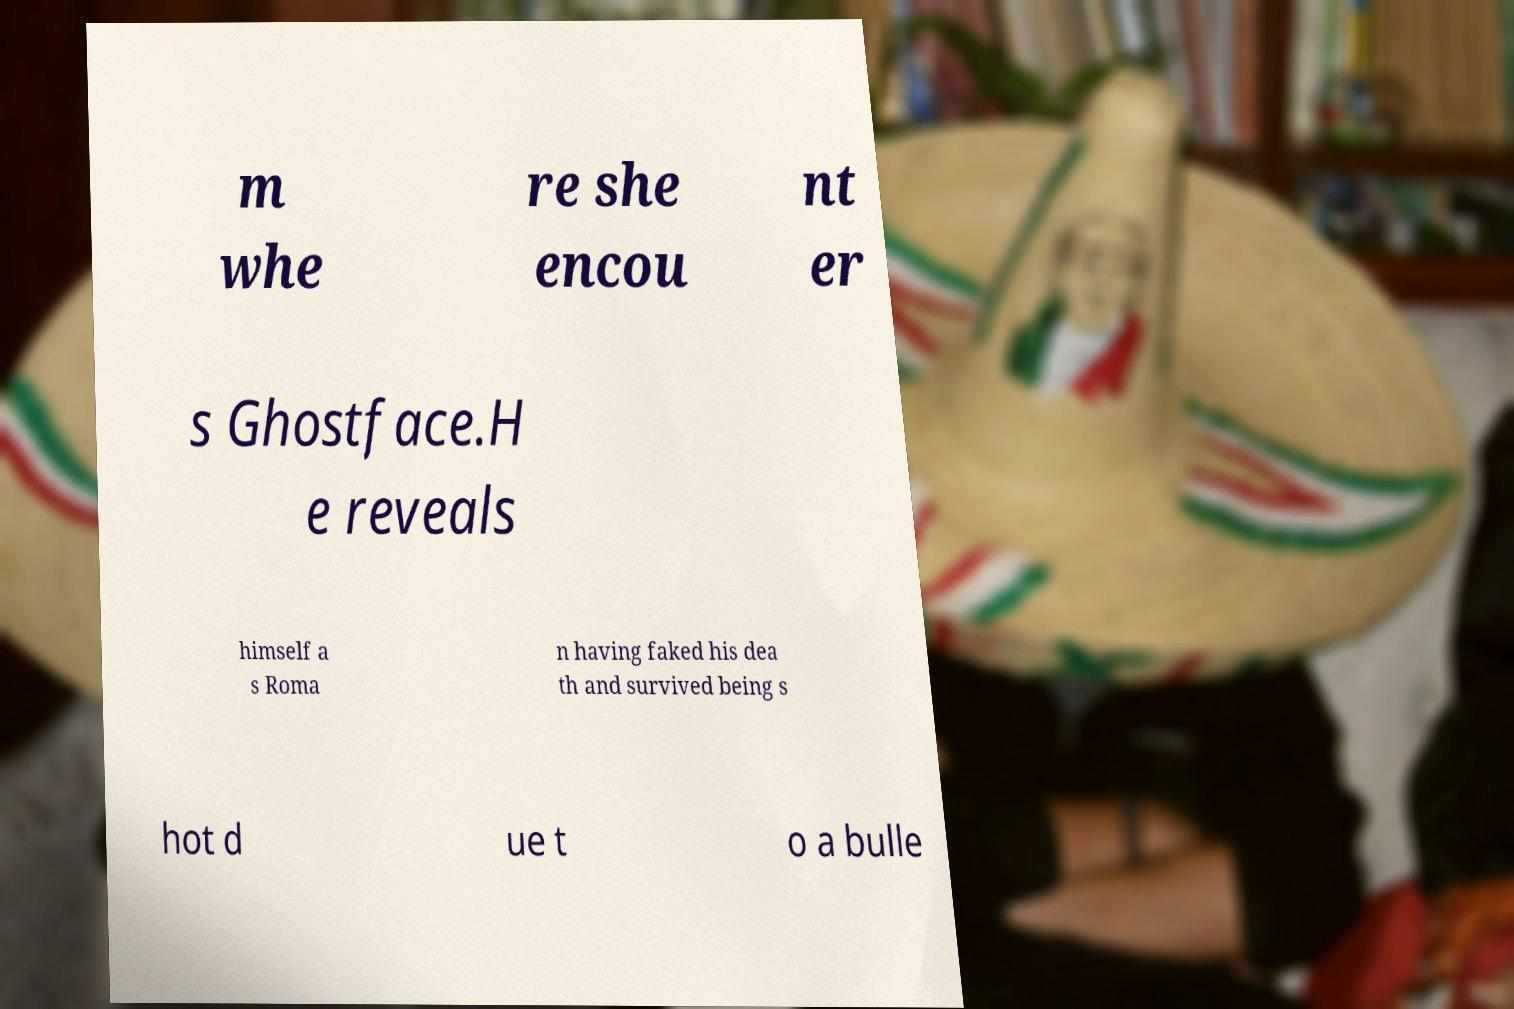Can you read and provide the text displayed in the image?This photo seems to have some interesting text. Can you extract and type it out for me? m whe re she encou nt er s Ghostface.H e reveals himself a s Roma n having faked his dea th and survived being s hot d ue t o a bulle 